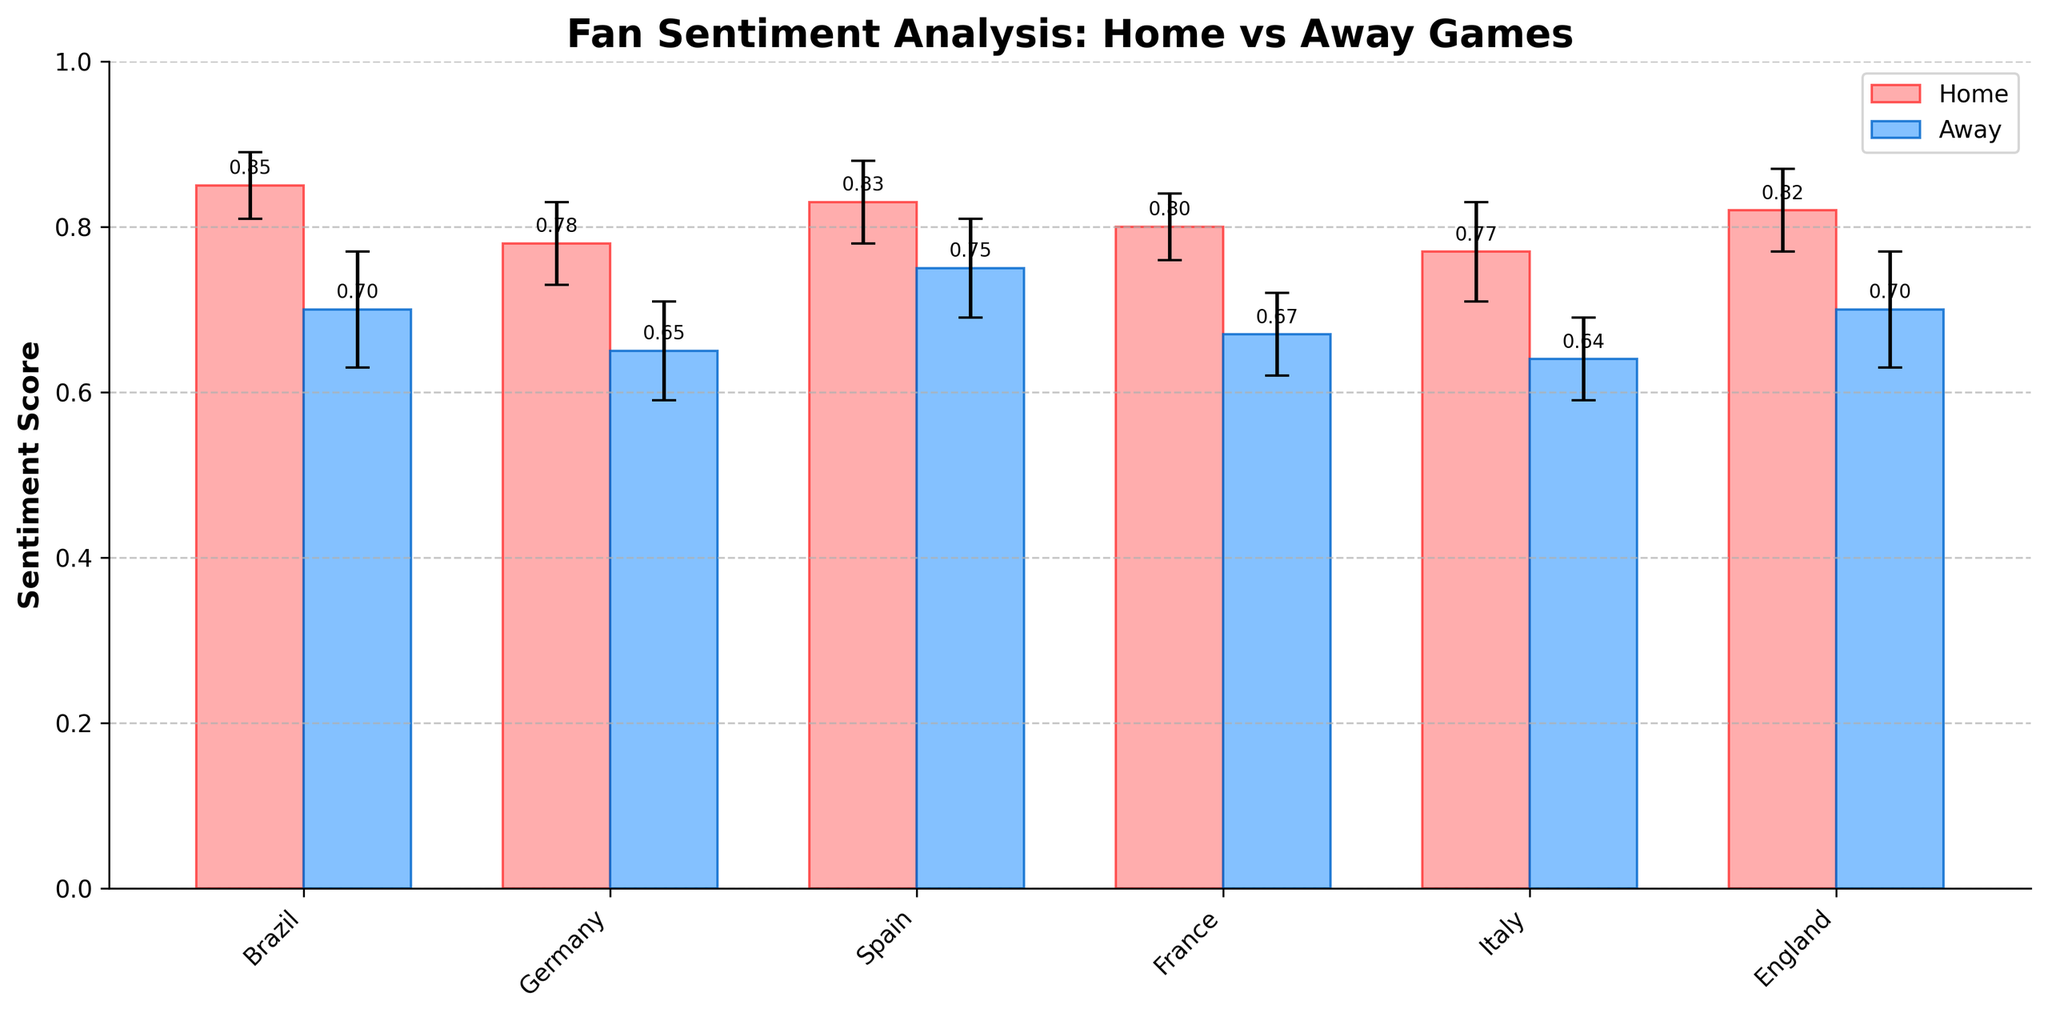What is the title of the figure? The title of the figure is displayed at the top and provides an overview of what the figure is about.
Answer: Fan Sentiment Analysis: Home vs Away Games Which country has the highest sentiment score for home games? Look at the bars representing home games and compare their heights to identify the tallest one.
Answer: Brazil What is the average sentiment score of home games? Sum all the sentiment scores for home games and divide by the number of data points (6). Sentiment scores: 0.85 (Brazil) + 0.78 (Germany) + 0.83 (Spain) + 0.80 (France) + 0.77 (Italy) + 0.82 (England). Total = 4.85; Average = 4.85 / 6 = 0.8083
Answer: 0.81 Which country has the largest difference in sentiment score between home and away games? Calculate the difference for each country: Brazil (0.85 - 0.70 = 0.15), Germany (0.78 - 0.65 = 0.13), Spain (0.83 - 0.75 = 0.08), France (0.80 - 0.67 = 0.13), Italy (0.77 - 0.64 = 0.13), England (0.82 - 0.70 = 0.12). Compare the differences to find the largest one.
Answer: Brazil What are the error values for the away games in Germany and France? Refer to the bars representing Germany and France in the away game category and read their error values.
Answer: Germany: 0.06, France: 0.05 Which country's fans have a more consistent sentiment between home and away games? Identify the country with the smallest difference between home and away sentiment scores: Brazil (0.15), Germany (0.13), Spain (0.08), France (0.13), Italy (0.13), England (0.12). Smallest difference is Spain with 0.08.
Answer: Spain How does the sentiment score for Italy's home game compare to its away game? Compare the heights of the bars for Italy in both home and away categories.
Answer: Higher at home What is the total sentiment score difference for England between home and away games? Subtract the away game sentiment score from the home game sentiment score for England: 0.82 - 0.70 = 0.12
Answer: 0.12 